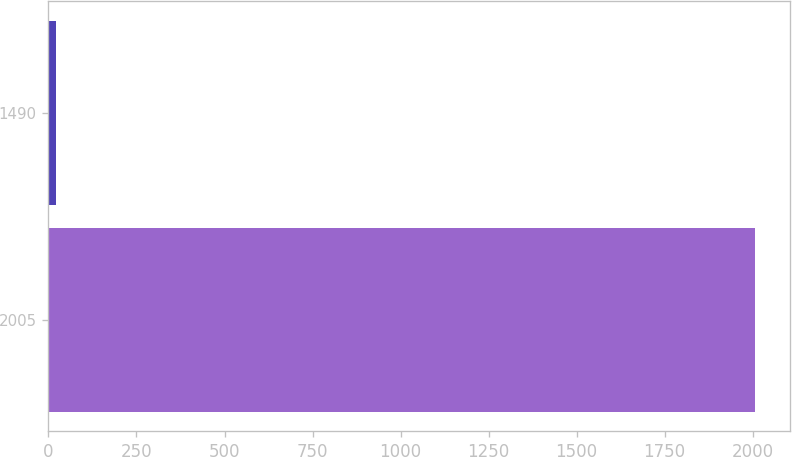Convert chart. <chart><loc_0><loc_0><loc_500><loc_500><bar_chart><fcel>2005<fcel>1490<nl><fcel>2007<fcel>21<nl></chart> 